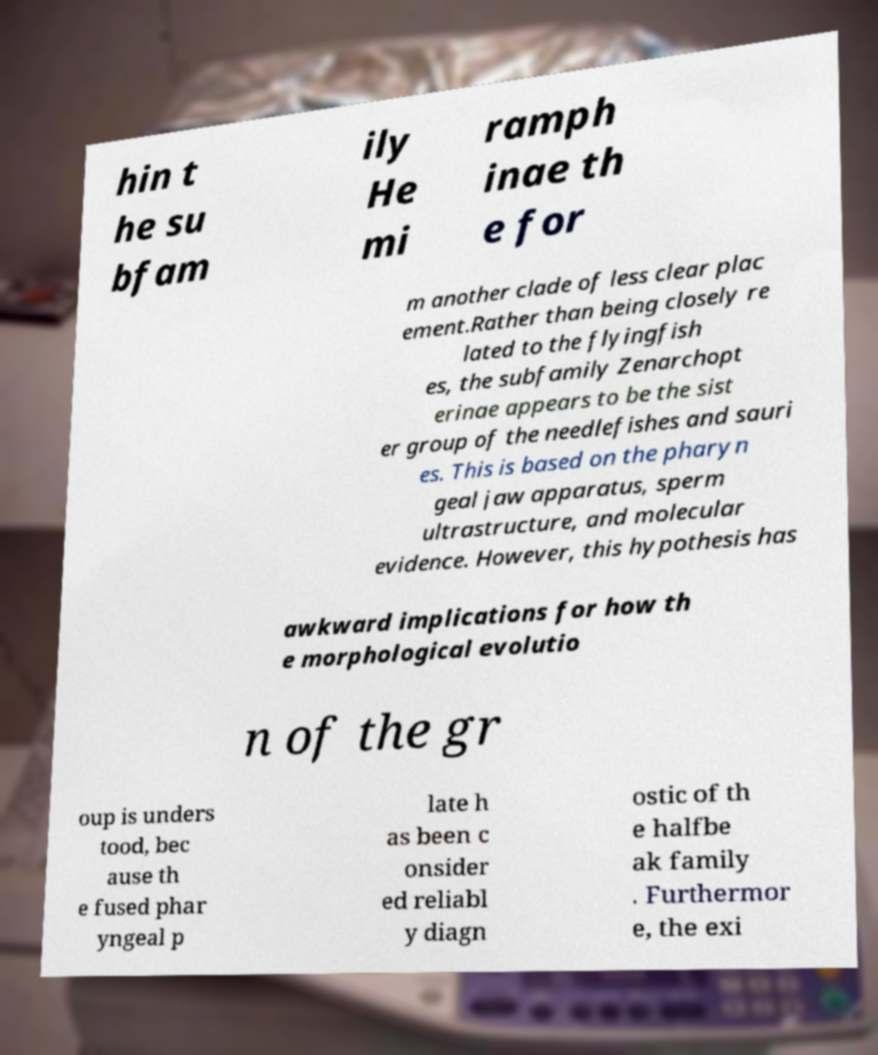For documentation purposes, I need the text within this image transcribed. Could you provide that? hin t he su bfam ily He mi ramph inae th e for m another clade of less clear plac ement.Rather than being closely re lated to the flyingfish es, the subfamily Zenarchopt erinae appears to be the sist er group of the needlefishes and sauri es. This is based on the pharyn geal jaw apparatus, sperm ultrastructure, and molecular evidence. However, this hypothesis has awkward implications for how th e morphological evolutio n of the gr oup is unders tood, bec ause th e fused phar yngeal p late h as been c onsider ed reliabl y diagn ostic of th e halfbe ak family . Furthermor e, the exi 